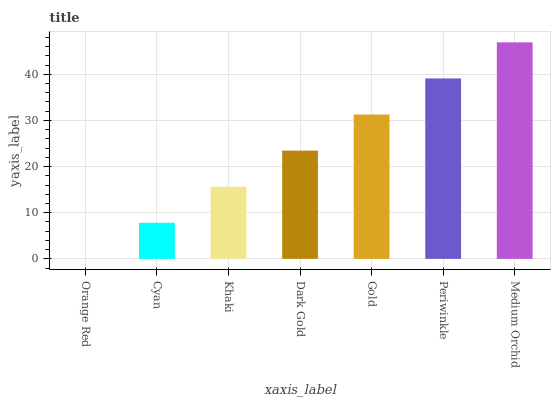Is Orange Red the minimum?
Answer yes or no. Yes. Is Medium Orchid the maximum?
Answer yes or no. Yes. Is Cyan the minimum?
Answer yes or no. No. Is Cyan the maximum?
Answer yes or no. No. Is Cyan greater than Orange Red?
Answer yes or no. Yes. Is Orange Red less than Cyan?
Answer yes or no. Yes. Is Orange Red greater than Cyan?
Answer yes or no. No. Is Cyan less than Orange Red?
Answer yes or no. No. Is Dark Gold the high median?
Answer yes or no. Yes. Is Dark Gold the low median?
Answer yes or no. Yes. Is Cyan the high median?
Answer yes or no. No. Is Cyan the low median?
Answer yes or no. No. 